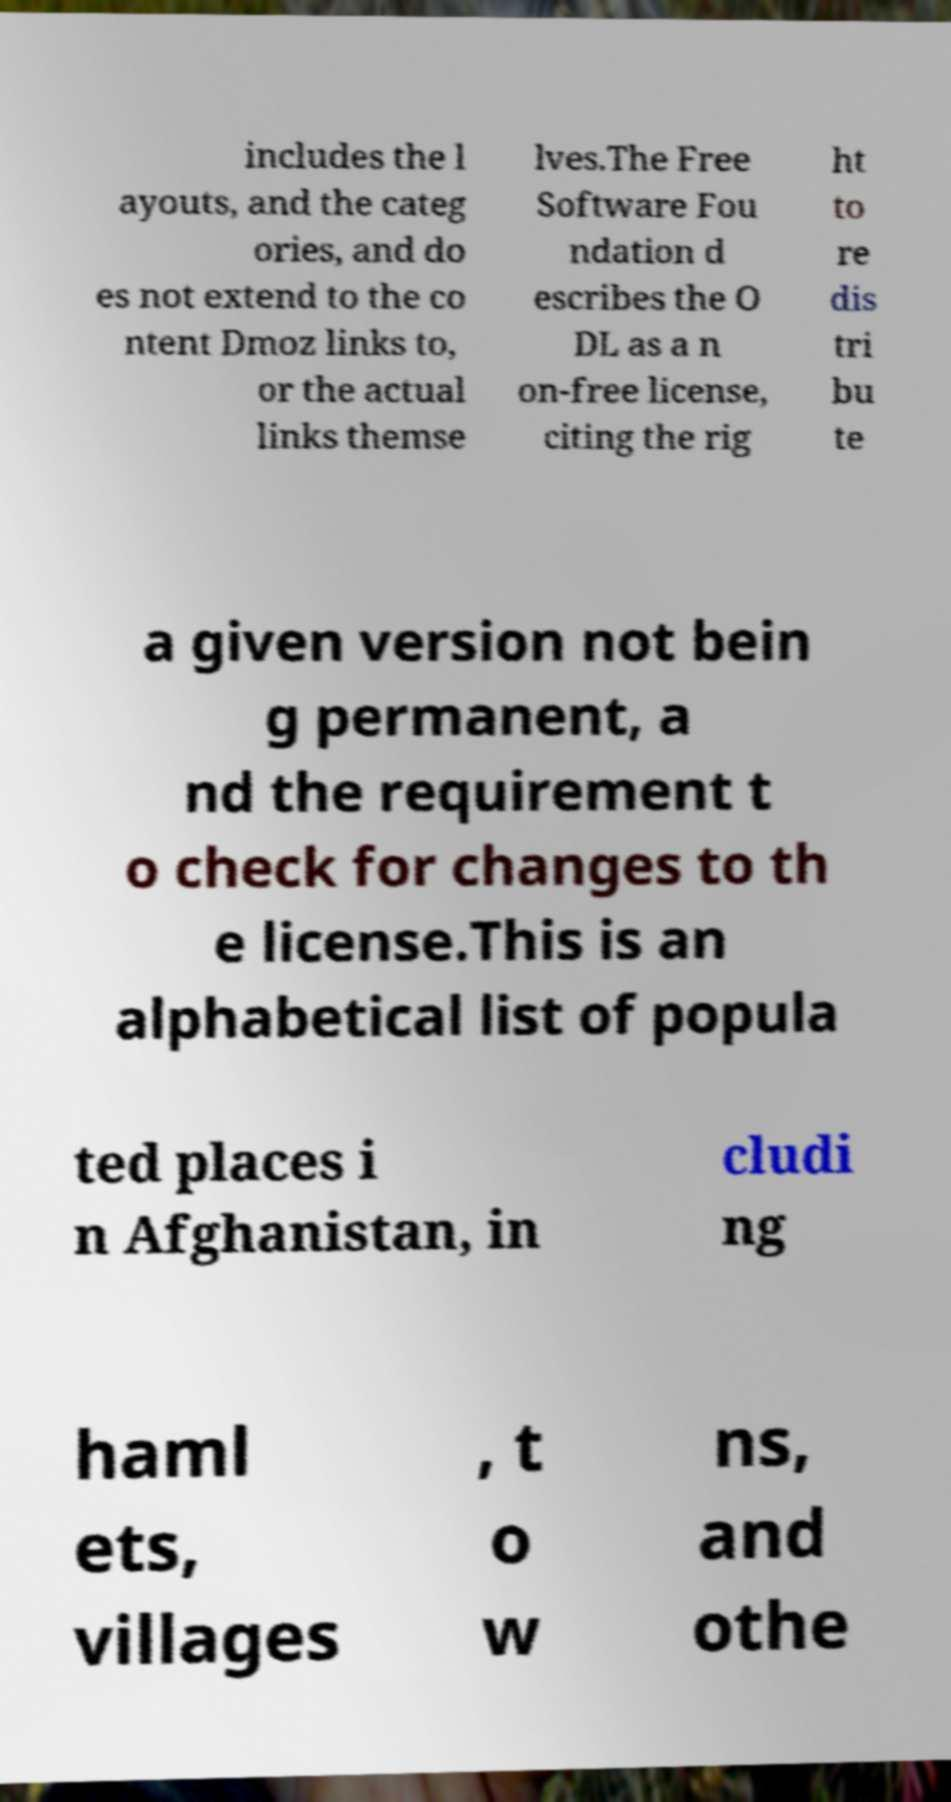Could you assist in decoding the text presented in this image and type it out clearly? includes the l ayouts, and the categ ories, and do es not extend to the co ntent Dmoz links to, or the actual links themse lves.The Free Software Fou ndation d escribes the O DL as a n on-free license, citing the rig ht to re dis tri bu te a given version not bein g permanent, a nd the requirement t o check for changes to th e license.This is an alphabetical list of popula ted places i n Afghanistan, in cludi ng haml ets, villages , t o w ns, and othe 